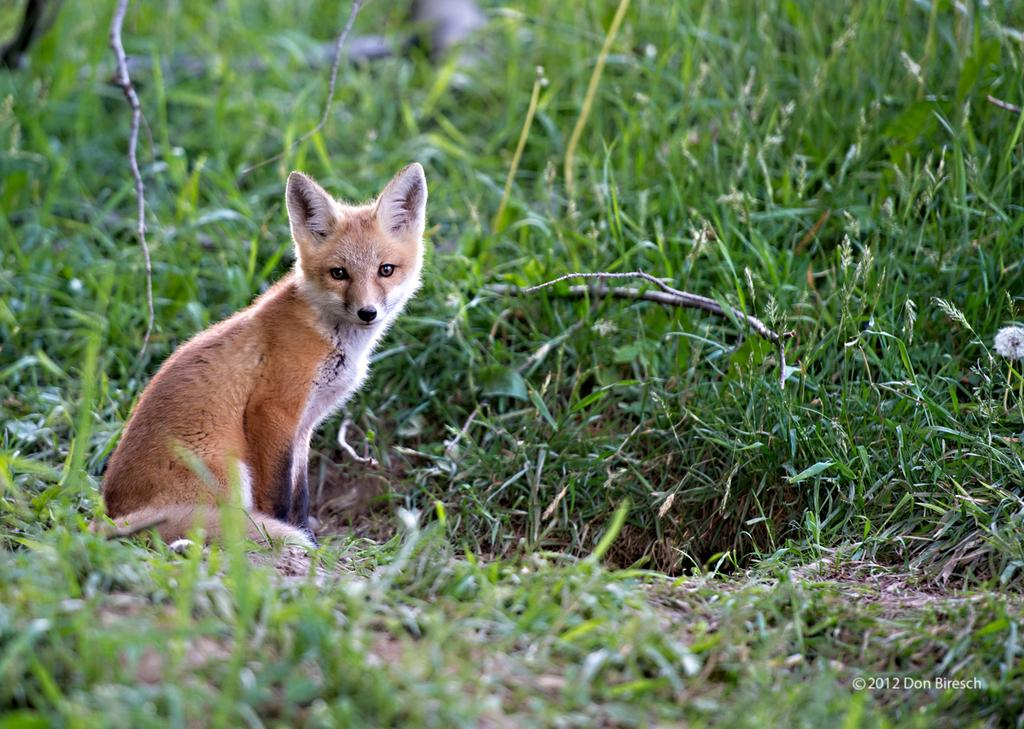What type of animal can be seen in the image? There is an animal in the image, but its specific type cannot be determined from the provided facts. Where is the animal located in the image? The animal is sitting in the grass. What color is the animal in the image? The animal is brown in color. What color is the grass in the image? The grass is green. Can you tell me how many socks are visible in the image? There are no socks present in the image. What type of trick is the animal performing in the image? There is no trick being performed by the animal in the image; it is simply sitting in the grass. 